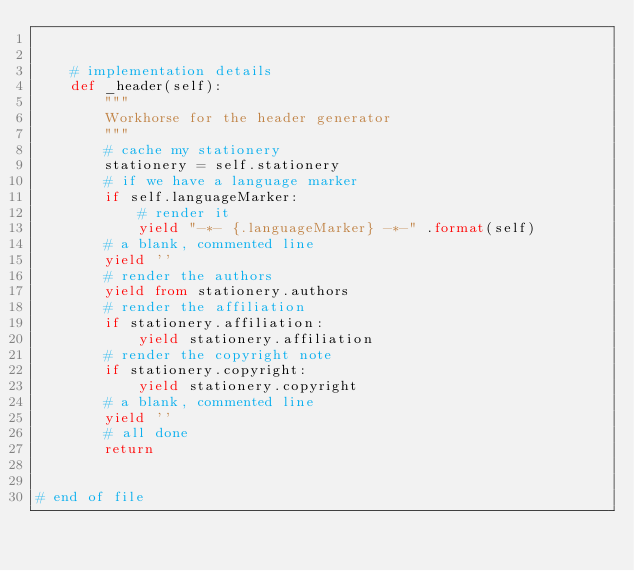Convert code to text. <code><loc_0><loc_0><loc_500><loc_500><_Python_>

    # implementation details
    def _header(self):
        """
        Workhorse for the header generator
        """
        # cache my stationery
        stationery = self.stationery
        # if we have a language marker
        if self.languageMarker:
            # render it
            yield "-*- {.languageMarker} -*-" .format(self)
        # a blank, commented line
        yield ''
        # render the authors
        yield from stationery.authors
        # render the affiliation
        if stationery.affiliation:
            yield stationery.affiliation
        # render the copyright note
        if stationery.copyright:
            yield stationery.copyright
        # a blank, commented line
        yield ''
        # all done
        return


# end of file
</code> 